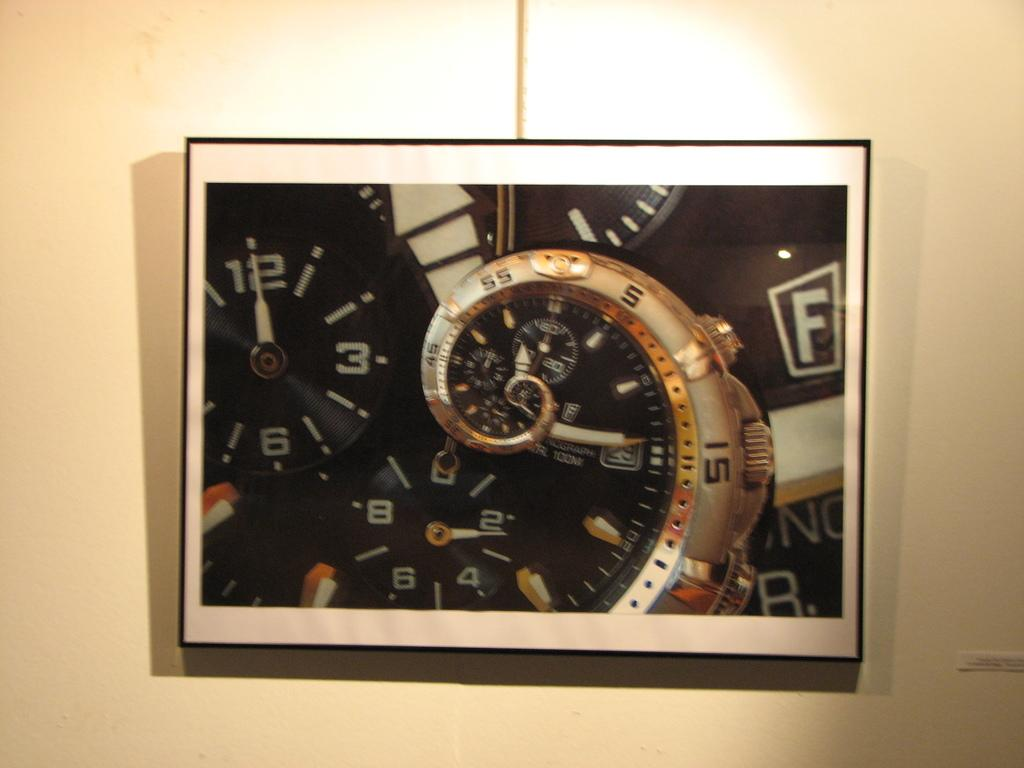Where was the image taken? The image was taken indoors. What can be seen in the background of the image? There is a wall in the background of the image. What is the main object in the middle of the image? There is a clock in the middle of the image, mounted on the wall. How many jellyfish are swimming in the image? There are no jellyfish present in the image. What part of the clock is visible in the image? The entire clock is visible in the image, as it is mounted on the wall. 